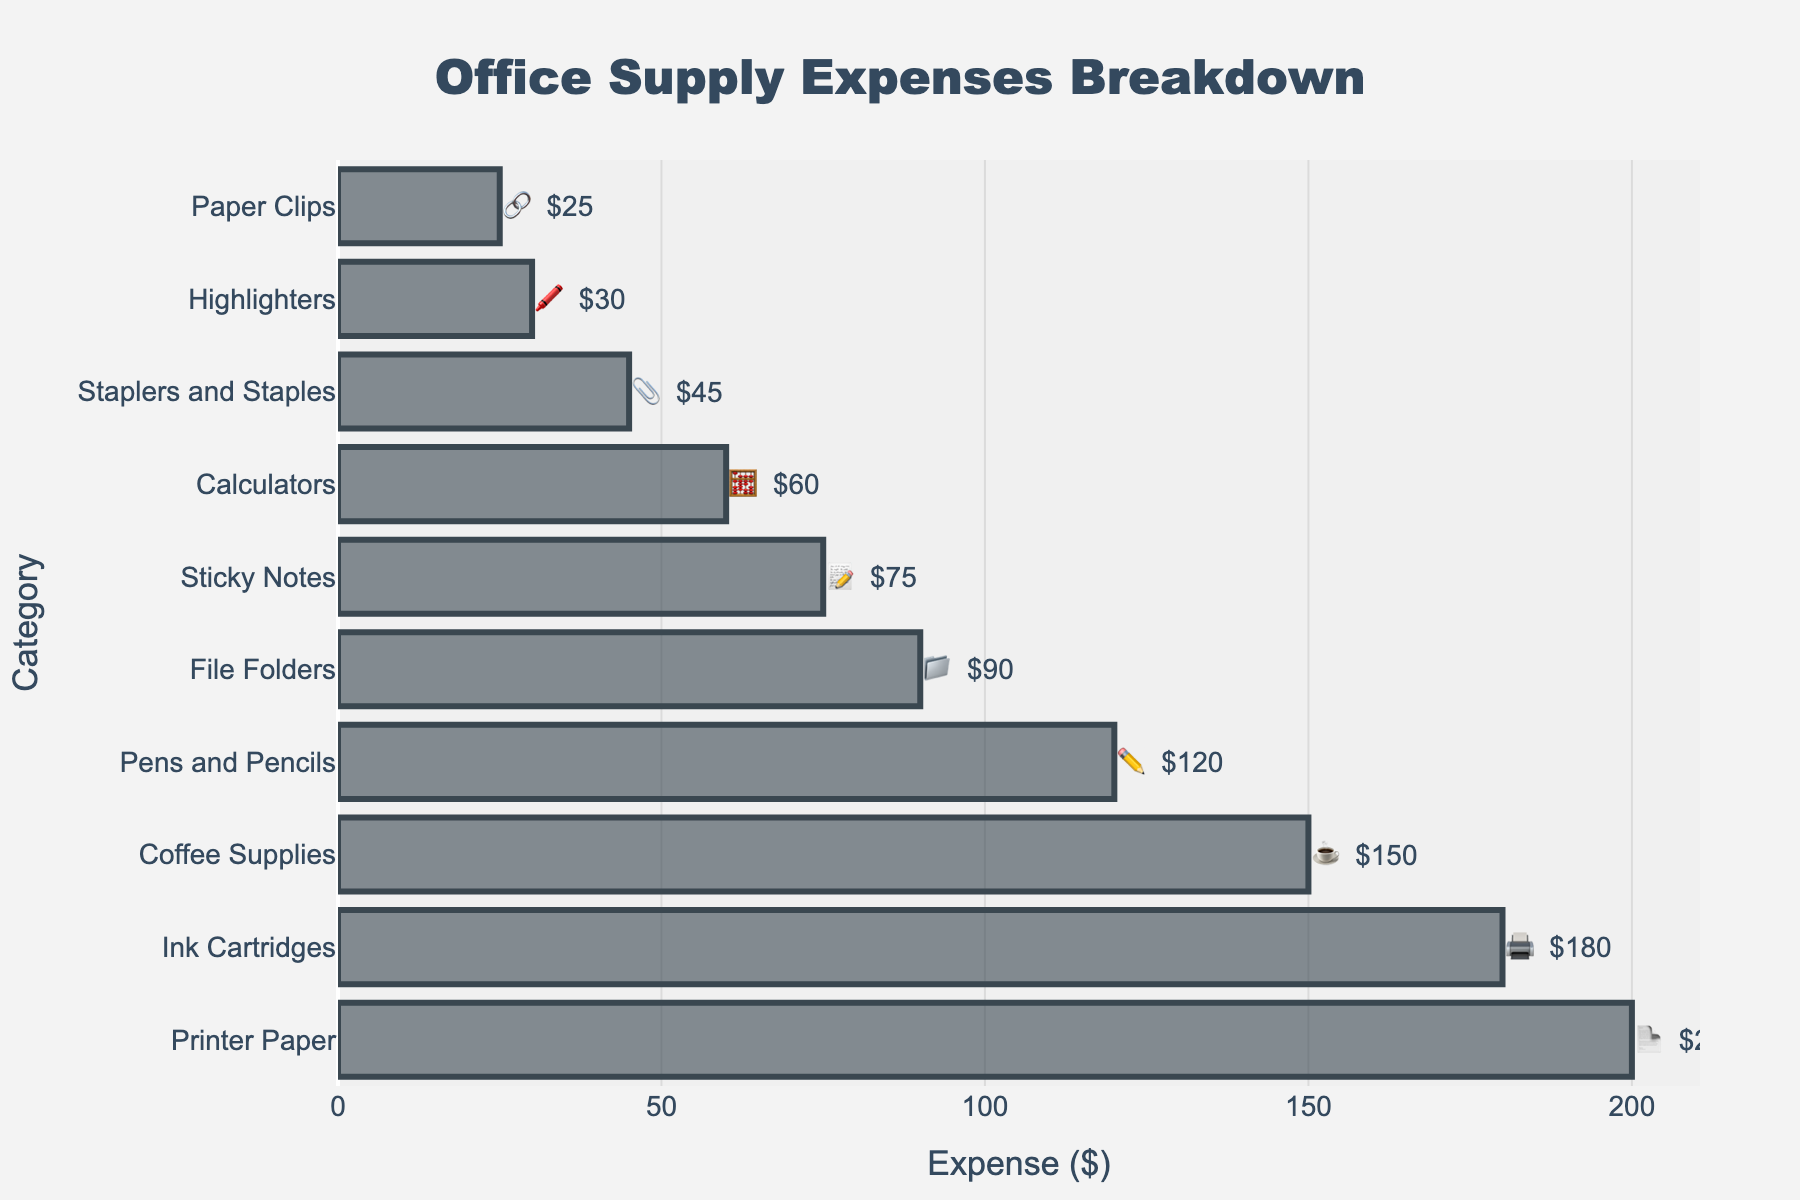What's the largest expense category? The largest expense can be determined by checking the horizontal bar with the longest length. The text on this bar will match the highest value.
Answer: Printer Paper 📄 Which category has the smallest expense? The smallest expense appears as the shortest bar in the chart. The text on this bar will match the lowest value.
Answer: Paper Clips 🔗 What is the title of the figure? The title of the figure is typically displayed at the top center of the chart. It is explicitly written there.
Answer: Office Supply Expenses Breakdown How many categories are listed in the chart? Count the number of horizontal bars presented in the figure. Each bar represents a category.
Answer: 10 What's the combined expense for Pens and Pencils ✏️ and Sticky Notes 📝? Identify the expenses for both categories and sum them up. Pens and Pencils cost $120 and Sticky Notes cost $75. So, 120 + 75 = 195.
Answer: 195 Which category has a higher expense: Ink Cartridges 🖨️ or Coffee Supplies ☕? Compare the lengths of the bars representing Ink Cartridges and Coffee Supplies. The text on each bar also indicates their respective expenses. Ink Cartridges cost $180, and Coffee Supplies cost $150. $180 > $150.
Answer: Ink Cartridges 🖨️ What's the expense difference between File Folders 📁 and Calculators 🧮? Identify the expenses for both categories and find the difference. File Folders cost $90 and Calculators cost $60. So, 90 - 60 = 30.
Answer: 30 Arrange the categories in increasing order of expense. List the expense categories from the shortest to the longest bar, considering the associated costs.
Answer: Paper Clips 🔗, Highlighters 🖍️, Staplers and Staples 📎, Calculators 🧮, Sticky Notes 📝, File Folders 📁, Pens and Pencils ✏️, Coffee Supplies ☕, Ink Cartridges 🖨️, Printer Paper 📄 What is the total expense for all the items combined? Sum all the expenses displayed on the bars in the chart. 120 + 200 + 45 + 75 + 180 + 90 + 60 + 30 + 150 + 25 = 975
Answer: 975 